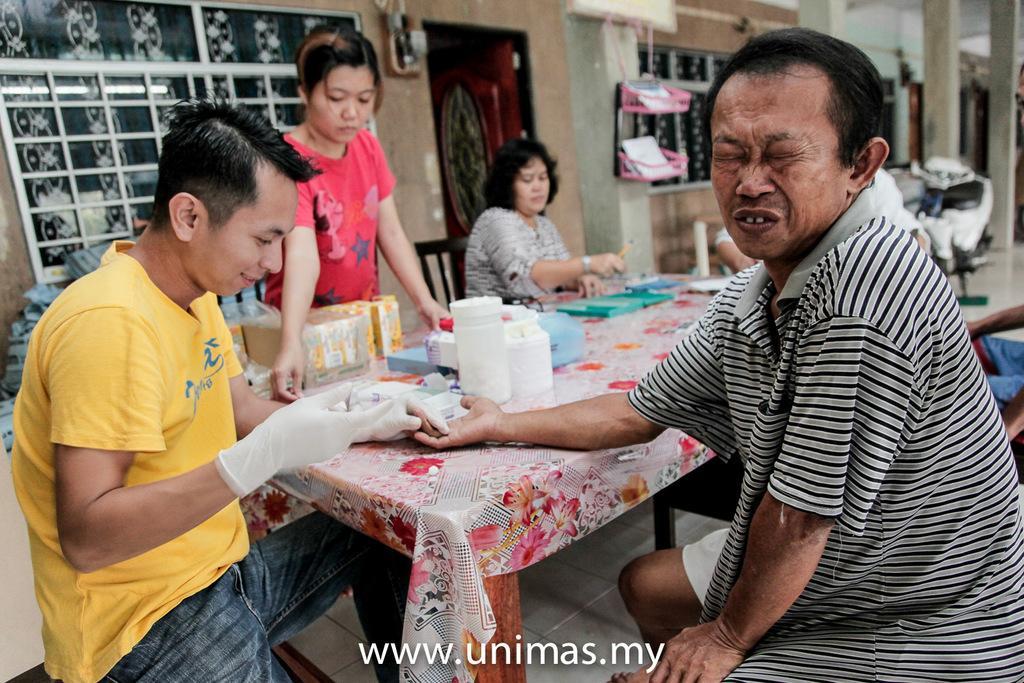In one or two sentences, can you explain what this image depicts? In this image there are four persons sitting on the chair. On the table there is a bottles,cardboard box,paper and some bottles in the tray. 